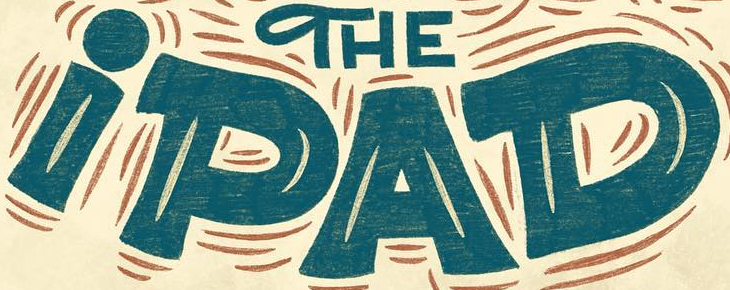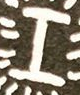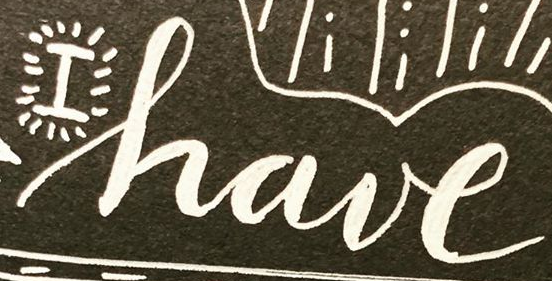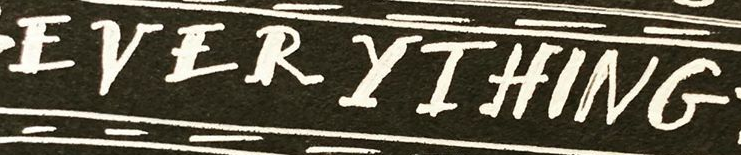Transcribe the words shown in these images in order, separated by a semicolon. iPAD; I; have; EVERYIHING 